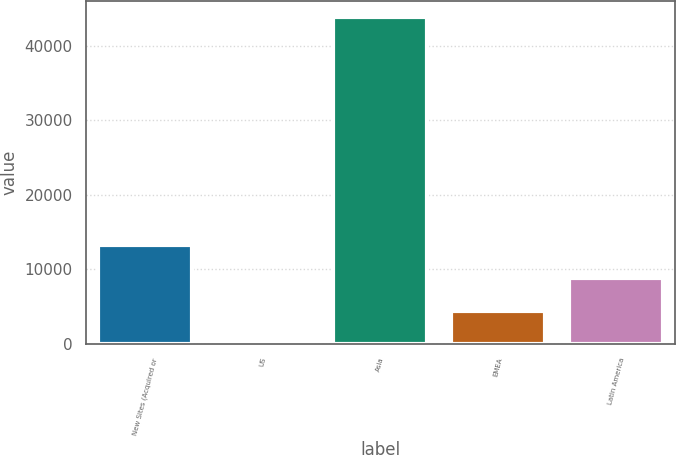Convert chart to OTSL. <chart><loc_0><loc_0><loc_500><loc_500><bar_chart><fcel>New Sites (Acquired or<fcel>US<fcel>Asia<fcel>EMEA<fcel>Latin America<nl><fcel>13205<fcel>65<fcel>43865<fcel>4445<fcel>8825<nl></chart> 